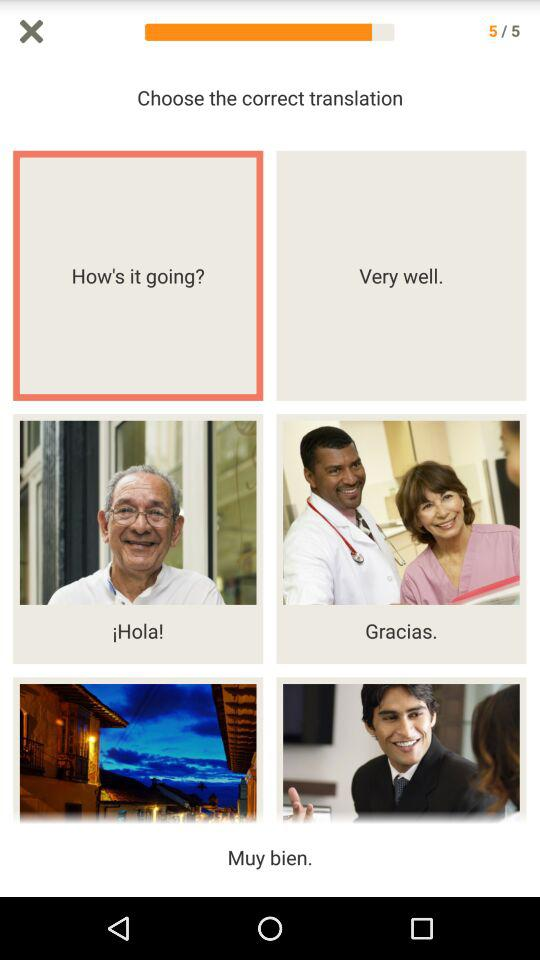How many total pages are there? There are 5 pages in total. 